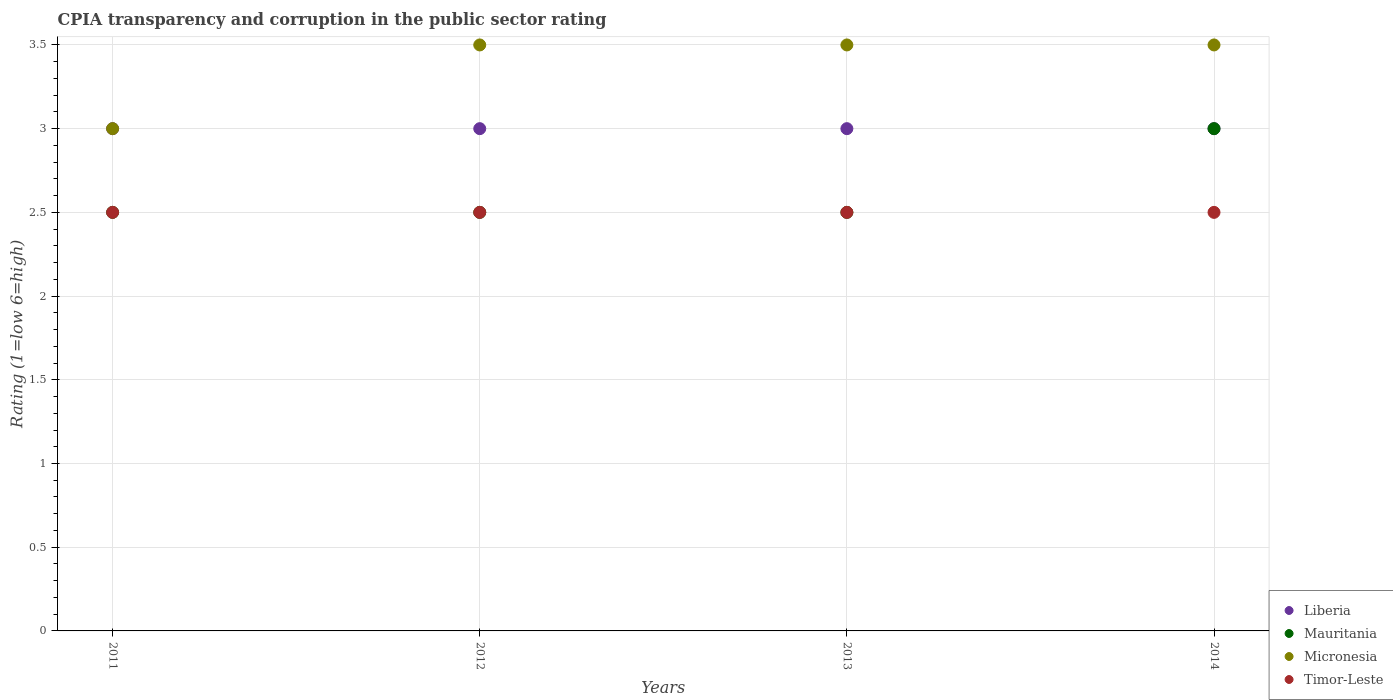How many different coloured dotlines are there?
Ensure brevity in your answer.  4. Is the number of dotlines equal to the number of legend labels?
Provide a short and direct response. Yes. In which year was the CPIA rating in Liberia maximum?
Ensure brevity in your answer.  2011. What is the difference between the CPIA rating in Micronesia in 2011 and that in 2013?
Your answer should be very brief. -0.5. What is the difference between the CPIA rating in Micronesia in 2013 and the CPIA rating in Timor-Leste in 2012?
Provide a short and direct response. 1. What is the average CPIA rating in Mauritania per year?
Your answer should be compact. 2.62. What is the difference between the highest and the second highest CPIA rating in Liberia?
Provide a short and direct response. 0. In how many years, is the CPIA rating in Mauritania greater than the average CPIA rating in Mauritania taken over all years?
Offer a terse response. 1. Is it the case that in every year, the sum of the CPIA rating in Timor-Leste and CPIA rating in Micronesia  is greater than the sum of CPIA rating in Mauritania and CPIA rating in Liberia?
Your answer should be very brief. No. Is it the case that in every year, the sum of the CPIA rating in Timor-Leste and CPIA rating in Liberia  is greater than the CPIA rating in Mauritania?
Provide a short and direct response. Yes. Is the CPIA rating in Timor-Leste strictly greater than the CPIA rating in Liberia over the years?
Keep it short and to the point. No. Is the CPIA rating in Timor-Leste strictly less than the CPIA rating in Micronesia over the years?
Keep it short and to the point. Yes. What is the difference between two consecutive major ticks on the Y-axis?
Offer a very short reply. 0.5. Are the values on the major ticks of Y-axis written in scientific E-notation?
Your response must be concise. No. Where does the legend appear in the graph?
Your answer should be very brief. Bottom right. How many legend labels are there?
Your answer should be compact. 4. How are the legend labels stacked?
Your response must be concise. Vertical. What is the title of the graph?
Make the answer very short. CPIA transparency and corruption in the public sector rating. Does "Channel Islands" appear as one of the legend labels in the graph?
Ensure brevity in your answer.  No. What is the label or title of the Y-axis?
Ensure brevity in your answer.  Rating (1=low 6=high). What is the Rating (1=low 6=high) in Mauritania in 2011?
Ensure brevity in your answer.  2.5. What is the Rating (1=low 6=high) in Timor-Leste in 2012?
Provide a short and direct response. 2.5. What is the Rating (1=low 6=high) of Liberia in 2014?
Offer a terse response. 3. Across all years, what is the maximum Rating (1=low 6=high) in Liberia?
Provide a short and direct response. 3. Across all years, what is the maximum Rating (1=low 6=high) in Mauritania?
Offer a very short reply. 3. Across all years, what is the minimum Rating (1=low 6=high) of Micronesia?
Offer a terse response. 3. Across all years, what is the minimum Rating (1=low 6=high) of Timor-Leste?
Provide a succinct answer. 2.5. What is the total Rating (1=low 6=high) of Liberia in the graph?
Your answer should be compact. 12. What is the total Rating (1=low 6=high) in Mauritania in the graph?
Keep it short and to the point. 10.5. What is the total Rating (1=low 6=high) in Micronesia in the graph?
Offer a terse response. 13.5. What is the total Rating (1=low 6=high) of Timor-Leste in the graph?
Make the answer very short. 10. What is the difference between the Rating (1=low 6=high) in Liberia in 2011 and that in 2012?
Ensure brevity in your answer.  0. What is the difference between the Rating (1=low 6=high) in Micronesia in 2011 and that in 2012?
Give a very brief answer. -0.5. What is the difference between the Rating (1=low 6=high) in Timor-Leste in 2011 and that in 2012?
Offer a very short reply. 0. What is the difference between the Rating (1=low 6=high) of Micronesia in 2011 and that in 2013?
Give a very brief answer. -0.5. What is the difference between the Rating (1=low 6=high) of Mauritania in 2011 and that in 2014?
Your response must be concise. -0.5. What is the difference between the Rating (1=low 6=high) in Micronesia in 2012 and that in 2013?
Offer a very short reply. 0. What is the difference between the Rating (1=low 6=high) of Liberia in 2012 and that in 2014?
Offer a very short reply. 0. What is the difference between the Rating (1=low 6=high) in Micronesia in 2012 and that in 2014?
Make the answer very short. 0. What is the difference between the Rating (1=low 6=high) in Liberia in 2013 and that in 2014?
Make the answer very short. 0. What is the difference between the Rating (1=low 6=high) of Liberia in 2011 and the Rating (1=low 6=high) of Mauritania in 2012?
Give a very brief answer. 0.5. What is the difference between the Rating (1=low 6=high) in Liberia in 2011 and the Rating (1=low 6=high) in Micronesia in 2012?
Make the answer very short. -0.5. What is the difference between the Rating (1=low 6=high) of Mauritania in 2011 and the Rating (1=low 6=high) of Timor-Leste in 2012?
Provide a succinct answer. 0. What is the difference between the Rating (1=low 6=high) of Micronesia in 2011 and the Rating (1=low 6=high) of Timor-Leste in 2013?
Give a very brief answer. 0.5. What is the difference between the Rating (1=low 6=high) of Liberia in 2011 and the Rating (1=low 6=high) of Mauritania in 2014?
Offer a terse response. 0. What is the difference between the Rating (1=low 6=high) of Liberia in 2011 and the Rating (1=low 6=high) of Micronesia in 2014?
Ensure brevity in your answer.  -0.5. What is the difference between the Rating (1=low 6=high) of Micronesia in 2011 and the Rating (1=low 6=high) of Timor-Leste in 2014?
Make the answer very short. 0.5. What is the difference between the Rating (1=low 6=high) in Liberia in 2012 and the Rating (1=low 6=high) in Mauritania in 2013?
Your answer should be very brief. 0.5. What is the difference between the Rating (1=low 6=high) of Liberia in 2012 and the Rating (1=low 6=high) of Micronesia in 2013?
Offer a very short reply. -0.5. What is the difference between the Rating (1=low 6=high) of Mauritania in 2012 and the Rating (1=low 6=high) of Timor-Leste in 2013?
Give a very brief answer. 0. What is the difference between the Rating (1=low 6=high) in Liberia in 2012 and the Rating (1=low 6=high) in Micronesia in 2014?
Provide a short and direct response. -0.5. What is the difference between the Rating (1=low 6=high) of Mauritania in 2012 and the Rating (1=low 6=high) of Timor-Leste in 2014?
Give a very brief answer. 0. What is the difference between the Rating (1=low 6=high) of Micronesia in 2012 and the Rating (1=low 6=high) of Timor-Leste in 2014?
Ensure brevity in your answer.  1. What is the difference between the Rating (1=low 6=high) in Liberia in 2013 and the Rating (1=low 6=high) in Mauritania in 2014?
Your answer should be very brief. 0. What is the difference between the Rating (1=low 6=high) in Liberia in 2013 and the Rating (1=low 6=high) in Micronesia in 2014?
Provide a succinct answer. -0.5. What is the difference between the Rating (1=low 6=high) in Liberia in 2013 and the Rating (1=low 6=high) in Timor-Leste in 2014?
Offer a very short reply. 0.5. What is the difference between the Rating (1=low 6=high) in Mauritania in 2013 and the Rating (1=low 6=high) in Micronesia in 2014?
Your response must be concise. -1. What is the average Rating (1=low 6=high) in Mauritania per year?
Your answer should be very brief. 2.62. What is the average Rating (1=low 6=high) of Micronesia per year?
Give a very brief answer. 3.38. In the year 2011, what is the difference between the Rating (1=low 6=high) of Liberia and Rating (1=low 6=high) of Micronesia?
Ensure brevity in your answer.  0. In the year 2011, what is the difference between the Rating (1=low 6=high) of Liberia and Rating (1=low 6=high) of Timor-Leste?
Your answer should be very brief. 0.5. In the year 2011, what is the difference between the Rating (1=low 6=high) in Mauritania and Rating (1=low 6=high) in Micronesia?
Your response must be concise. -0.5. In the year 2012, what is the difference between the Rating (1=low 6=high) of Liberia and Rating (1=low 6=high) of Mauritania?
Your answer should be compact. 0.5. In the year 2012, what is the difference between the Rating (1=low 6=high) in Liberia and Rating (1=low 6=high) in Micronesia?
Make the answer very short. -0.5. In the year 2012, what is the difference between the Rating (1=low 6=high) of Mauritania and Rating (1=low 6=high) of Micronesia?
Ensure brevity in your answer.  -1. In the year 2012, what is the difference between the Rating (1=low 6=high) in Mauritania and Rating (1=low 6=high) in Timor-Leste?
Your answer should be compact. 0. In the year 2012, what is the difference between the Rating (1=low 6=high) in Micronesia and Rating (1=low 6=high) in Timor-Leste?
Make the answer very short. 1. In the year 2013, what is the difference between the Rating (1=low 6=high) of Liberia and Rating (1=low 6=high) of Mauritania?
Ensure brevity in your answer.  0.5. In the year 2013, what is the difference between the Rating (1=low 6=high) of Liberia and Rating (1=low 6=high) of Micronesia?
Keep it short and to the point. -0.5. In the year 2013, what is the difference between the Rating (1=low 6=high) of Mauritania and Rating (1=low 6=high) of Timor-Leste?
Offer a terse response. 0. In the year 2013, what is the difference between the Rating (1=low 6=high) of Micronesia and Rating (1=low 6=high) of Timor-Leste?
Offer a terse response. 1. In the year 2014, what is the difference between the Rating (1=low 6=high) in Liberia and Rating (1=low 6=high) in Micronesia?
Your response must be concise. -0.5. What is the ratio of the Rating (1=low 6=high) in Mauritania in 2011 to that in 2012?
Provide a short and direct response. 1. What is the ratio of the Rating (1=low 6=high) of Timor-Leste in 2011 to that in 2012?
Keep it short and to the point. 1. What is the ratio of the Rating (1=low 6=high) in Micronesia in 2011 to that in 2013?
Your answer should be compact. 0.86. What is the ratio of the Rating (1=low 6=high) in Liberia in 2011 to that in 2014?
Your response must be concise. 1. What is the ratio of the Rating (1=low 6=high) in Liberia in 2012 to that in 2013?
Offer a very short reply. 1. What is the ratio of the Rating (1=low 6=high) in Mauritania in 2012 to that in 2013?
Give a very brief answer. 1. What is the ratio of the Rating (1=low 6=high) of Liberia in 2012 to that in 2014?
Your response must be concise. 1. What is the ratio of the Rating (1=low 6=high) in Mauritania in 2012 to that in 2014?
Provide a short and direct response. 0.83. What is the ratio of the Rating (1=low 6=high) of Micronesia in 2012 to that in 2014?
Provide a short and direct response. 1. What is the ratio of the Rating (1=low 6=high) in Timor-Leste in 2012 to that in 2014?
Offer a very short reply. 1. What is the ratio of the Rating (1=low 6=high) of Liberia in 2013 to that in 2014?
Your answer should be compact. 1. What is the ratio of the Rating (1=low 6=high) in Timor-Leste in 2013 to that in 2014?
Offer a very short reply. 1. What is the difference between the highest and the second highest Rating (1=low 6=high) of Micronesia?
Provide a short and direct response. 0. What is the difference between the highest and the lowest Rating (1=low 6=high) in Liberia?
Make the answer very short. 0. What is the difference between the highest and the lowest Rating (1=low 6=high) of Micronesia?
Provide a short and direct response. 0.5. What is the difference between the highest and the lowest Rating (1=low 6=high) of Timor-Leste?
Your response must be concise. 0. 